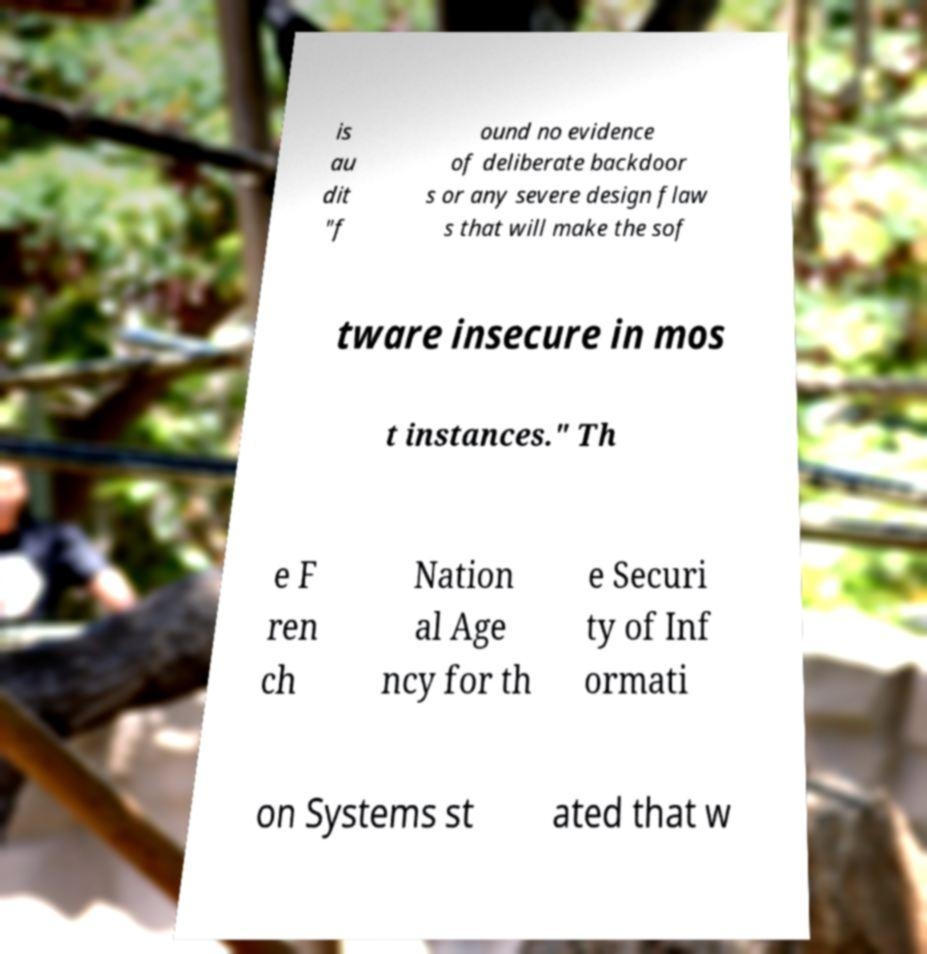Can you read and provide the text displayed in the image?This photo seems to have some interesting text. Can you extract and type it out for me? is au dit "f ound no evidence of deliberate backdoor s or any severe design flaw s that will make the sof tware insecure in mos t instances." Th e F ren ch Nation al Age ncy for th e Securi ty of Inf ormati on Systems st ated that w 